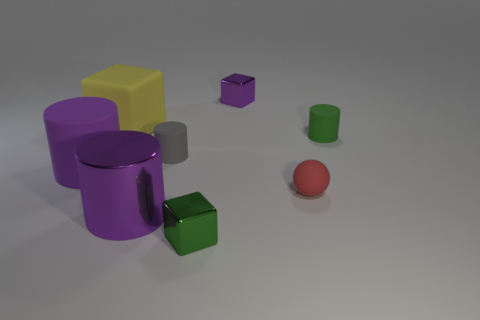Are there any other things that are the same material as the yellow object?
Keep it short and to the point. Yes. Are there any small blocks that have the same color as the big matte cube?
Your response must be concise. No. Are there fewer large purple matte things that are behind the big yellow matte cube than purple cubes left of the small green metal cube?
Keep it short and to the point. No. What is the material of the block that is behind the gray matte cylinder and to the right of the small gray cylinder?
Provide a succinct answer. Metal. Do the tiny purple thing and the large purple thing in front of the large purple rubber thing have the same shape?
Offer a terse response. No. How many other objects are the same size as the green cube?
Your answer should be compact. 4. Are there more rubber blocks than big matte objects?
Your answer should be very brief. No. What number of rubber objects are to the right of the tiny purple shiny block and in front of the gray rubber cylinder?
Your answer should be compact. 1. What shape is the metallic object behind the cylinder that is in front of the purple cylinder to the left of the big shiny cylinder?
Provide a succinct answer. Cube. Is there any other thing that is the same shape as the tiny purple shiny thing?
Provide a short and direct response. Yes. 